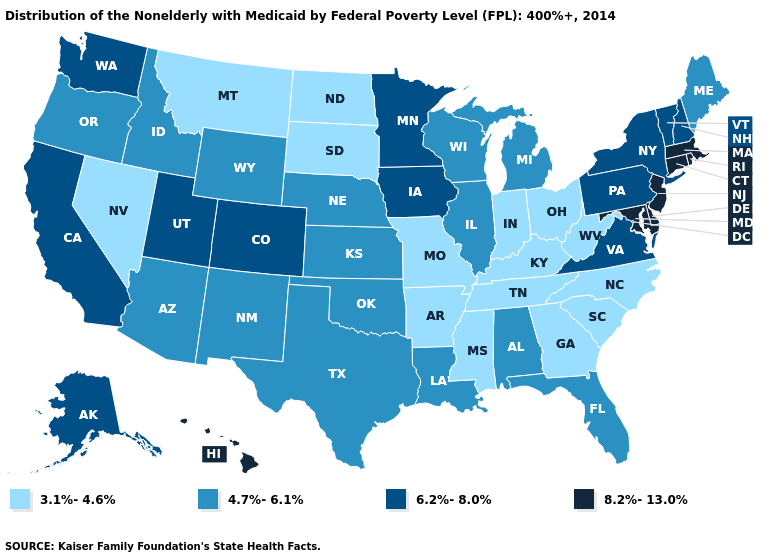Among the states that border South Dakota , does North Dakota have the lowest value?
Keep it brief. Yes. What is the lowest value in the Northeast?
Give a very brief answer. 4.7%-6.1%. Name the states that have a value in the range 8.2%-13.0%?
Write a very short answer. Connecticut, Delaware, Hawaii, Maryland, Massachusetts, New Jersey, Rhode Island. Name the states that have a value in the range 3.1%-4.6%?
Be succinct. Arkansas, Georgia, Indiana, Kentucky, Mississippi, Missouri, Montana, Nevada, North Carolina, North Dakota, Ohio, South Carolina, South Dakota, Tennessee, West Virginia. What is the value of Alabama?
Keep it brief. 4.7%-6.1%. What is the value of Hawaii?
Concise answer only. 8.2%-13.0%. Name the states that have a value in the range 8.2%-13.0%?
Answer briefly. Connecticut, Delaware, Hawaii, Maryland, Massachusetts, New Jersey, Rhode Island. What is the lowest value in states that border Indiana?
Answer briefly. 3.1%-4.6%. Among the states that border Illinois , does Wisconsin have the lowest value?
Quick response, please. No. Name the states that have a value in the range 3.1%-4.6%?
Keep it brief. Arkansas, Georgia, Indiana, Kentucky, Mississippi, Missouri, Montana, Nevada, North Carolina, North Dakota, Ohio, South Carolina, South Dakota, Tennessee, West Virginia. Does Tennessee have a lower value than Alabama?
Quick response, please. Yes. Name the states that have a value in the range 4.7%-6.1%?
Keep it brief. Alabama, Arizona, Florida, Idaho, Illinois, Kansas, Louisiana, Maine, Michigan, Nebraska, New Mexico, Oklahoma, Oregon, Texas, Wisconsin, Wyoming. What is the value of Maine?
Be succinct. 4.7%-6.1%. Name the states that have a value in the range 3.1%-4.6%?
Write a very short answer. Arkansas, Georgia, Indiana, Kentucky, Mississippi, Missouri, Montana, Nevada, North Carolina, North Dakota, Ohio, South Carolina, South Dakota, Tennessee, West Virginia. Does the first symbol in the legend represent the smallest category?
Quick response, please. Yes. 